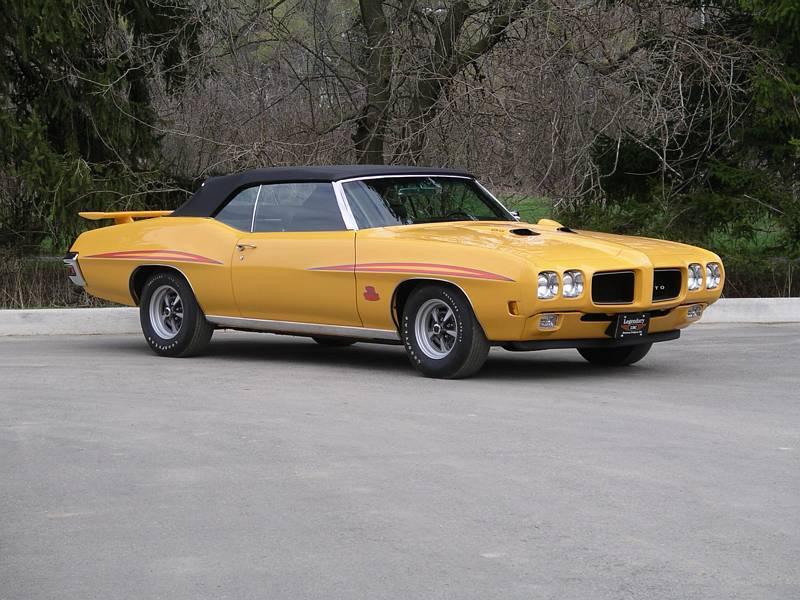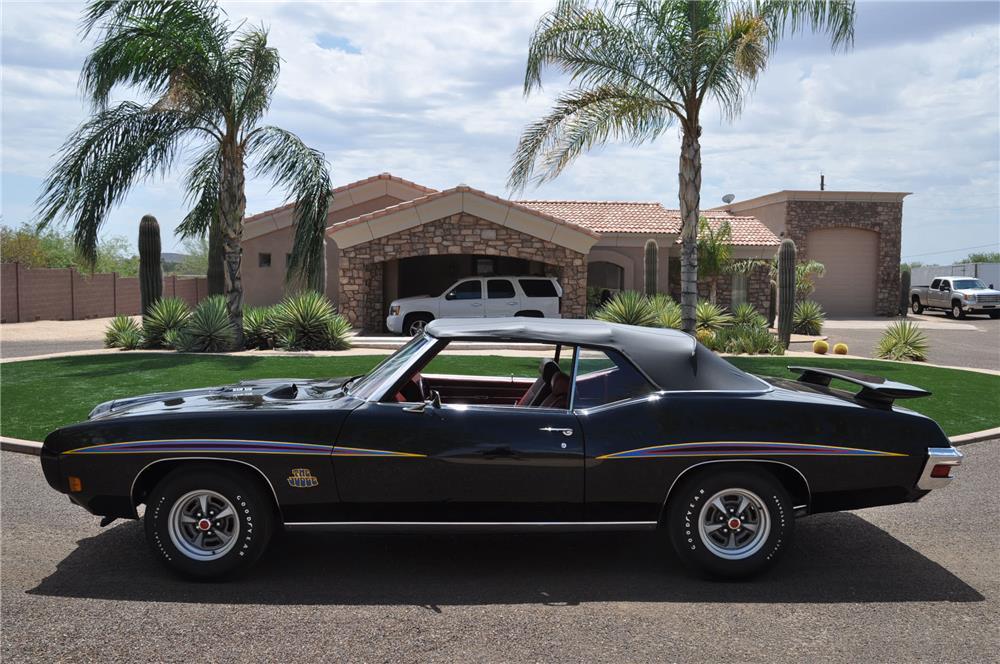The first image is the image on the left, the second image is the image on the right. For the images displayed, is the sentence "At least one car has its top down." factually correct? Answer yes or no. No. 